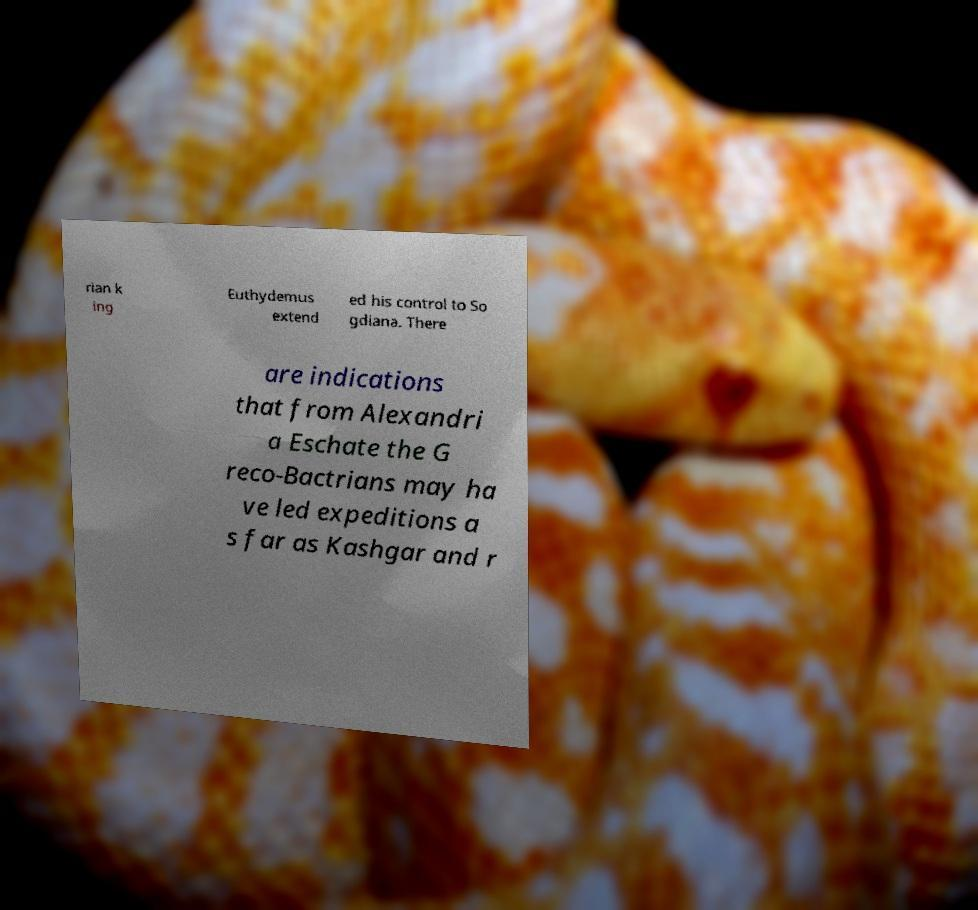Please read and relay the text visible in this image. What does it say? rian k ing Euthydemus extend ed his control to So gdiana. There are indications that from Alexandri a Eschate the G reco-Bactrians may ha ve led expeditions a s far as Kashgar and r 